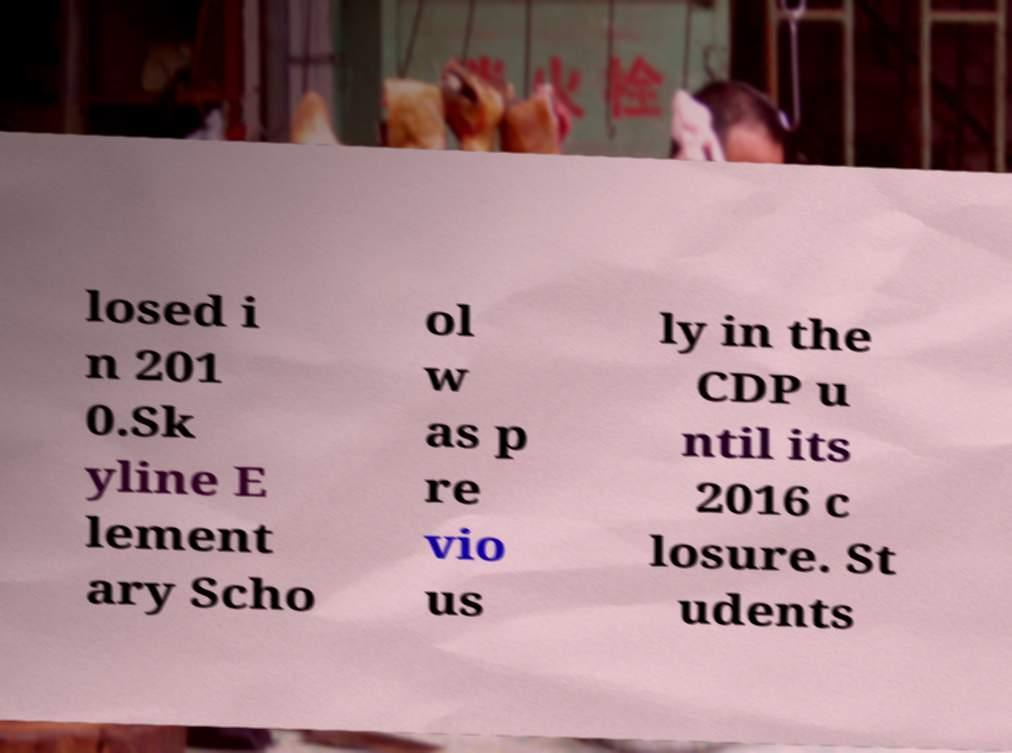For documentation purposes, I need the text within this image transcribed. Could you provide that? losed i n 201 0.Sk yline E lement ary Scho ol w as p re vio us ly in the CDP u ntil its 2016 c losure. St udents 